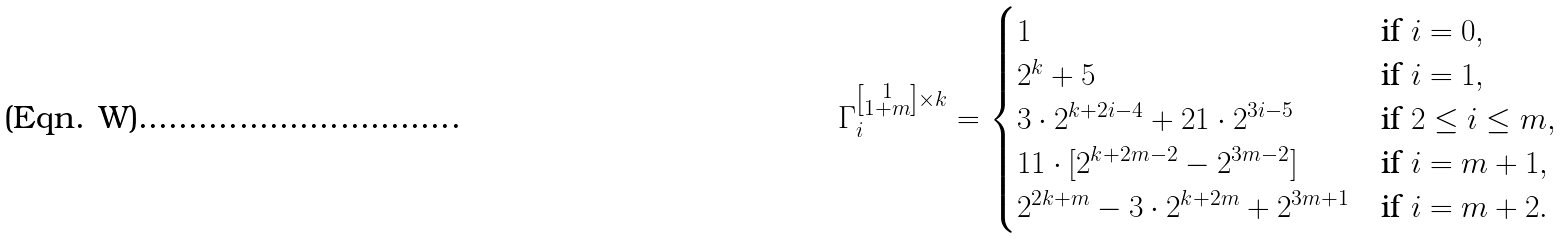Convert formula to latex. <formula><loc_0><loc_0><loc_500><loc_500>\Gamma _ { i } ^ { \left [ \substack { 1 \\ 1 + m } \right ] \times k } = \begin{cases} 1 & \text {if } i = 0 , \\ 2 ^ { k } + 5 & \text {if } i = 1 , \\ 3 \cdot 2 ^ { k + 2 i - 4 } + 2 1 \cdot 2 ^ { 3 i - 5 } & \text {if  } 2 \leq i \leq m , \\ 1 1 \cdot [ 2 ^ { k + 2 m - 2 } - 2 ^ { 3 m - 2 } ] & \text {if  } i = m + 1 , \\ 2 ^ { 2 k + m } - 3 \cdot 2 ^ { k + 2 m } + 2 ^ { 3 m + 1 } & \text {if  } i = m + 2 . \end{cases}</formula> 